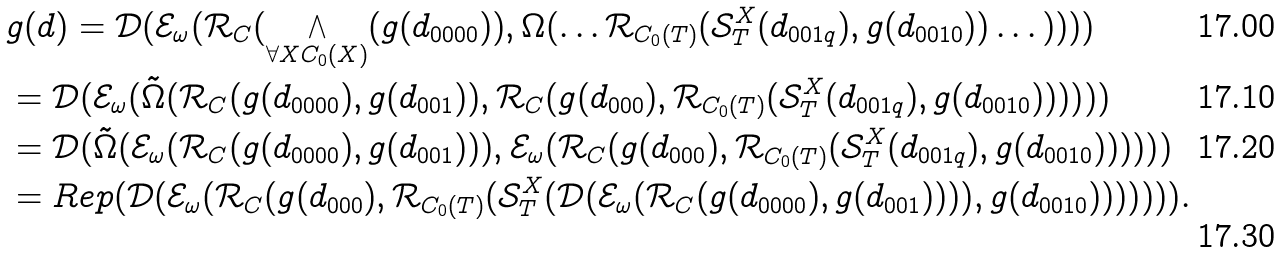Convert formula to latex. <formula><loc_0><loc_0><loc_500><loc_500>& g ( d ) = \mathcal { D } ( \mathcal { E } _ { \omega } ( \mathcal { R } _ { C } ( \bigwedge _ { \forall X C _ { 0 } ( X ) } ( g ( d _ { 0 0 0 0 } ) ) , \Omega ( \dots \mathcal { R } _ { C _ { 0 } ( T ) } ( \mathcal { S } ^ { X } _ { T } ( d _ { 0 0 1 q } ) , g ( d _ { 0 0 1 0 } ) ) \dots ) ) ) ) \\ & = \mathcal { D } ( \mathcal { E } _ { \omega } ( \tilde { \Omega } ( \mathcal { R } _ { C } ( g ( d _ { 0 0 0 0 } ) , g ( d _ { 0 0 1 } ) ) , \mathcal { R } _ { C } ( g ( d _ { 0 0 0 } ) , \mathcal { R } _ { C _ { 0 } ( T ) } ( \mathcal { S } ^ { X } _ { T } ( d _ { 0 0 1 q } ) , g ( d _ { 0 0 1 0 } ) ) ) ) ) ) \\ & = \mathcal { D } ( \tilde { \Omega } ( \mathcal { E } _ { \omega } ( \mathcal { R } _ { C } ( g ( d _ { 0 0 0 0 } ) , g ( d _ { 0 0 1 } ) ) ) , \mathcal { E } _ { \omega } ( \mathcal { R } _ { C } ( g ( d _ { 0 0 0 } ) , \mathcal { R } _ { C _ { 0 } ( T ) } ( \mathcal { S } ^ { X } _ { T } ( d _ { 0 0 1 q } ) , g ( d _ { 0 0 1 0 } ) ) ) ) ) ) \\ & = R e p ( \mathcal { D } ( \mathcal { E } _ { \omega } ( \mathcal { R } _ { C } ( g ( d _ { 0 0 0 } ) , \mathcal { R } _ { C _ { 0 } ( T ) } ( \mathcal { S } ^ { X } _ { T } ( \mathcal { D } ( \mathcal { E } _ { \omega } ( \mathcal { R } _ { C } ( g ( d _ { 0 0 0 0 } ) , g ( d _ { 0 0 1 } ) ) ) ) , g ( d _ { 0 0 1 0 } ) ) ) ) ) ) ) .</formula> 